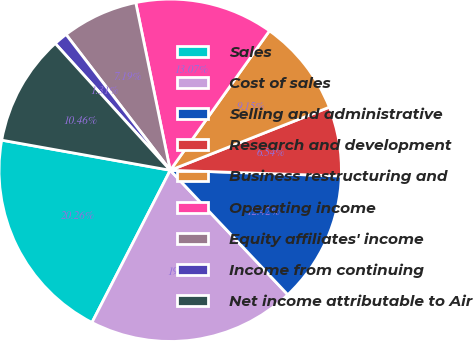Convert chart. <chart><loc_0><loc_0><loc_500><loc_500><pie_chart><fcel>Sales<fcel>Cost of sales<fcel>Selling and administrative<fcel>Research and development<fcel>Business restructuring and<fcel>Operating income<fcel>Equity affiliates' income<fcel>Income from continuing<fcel>Net income attributable to Air<nl><fcel>20.26%<fcel>19.61%<fcel>12.42%<fcel>6.54%<fcel>9.15%<fcel>13.07%<fcel>7.19%<fcel>1.31%<fcel>10.46%<nl></chart> 